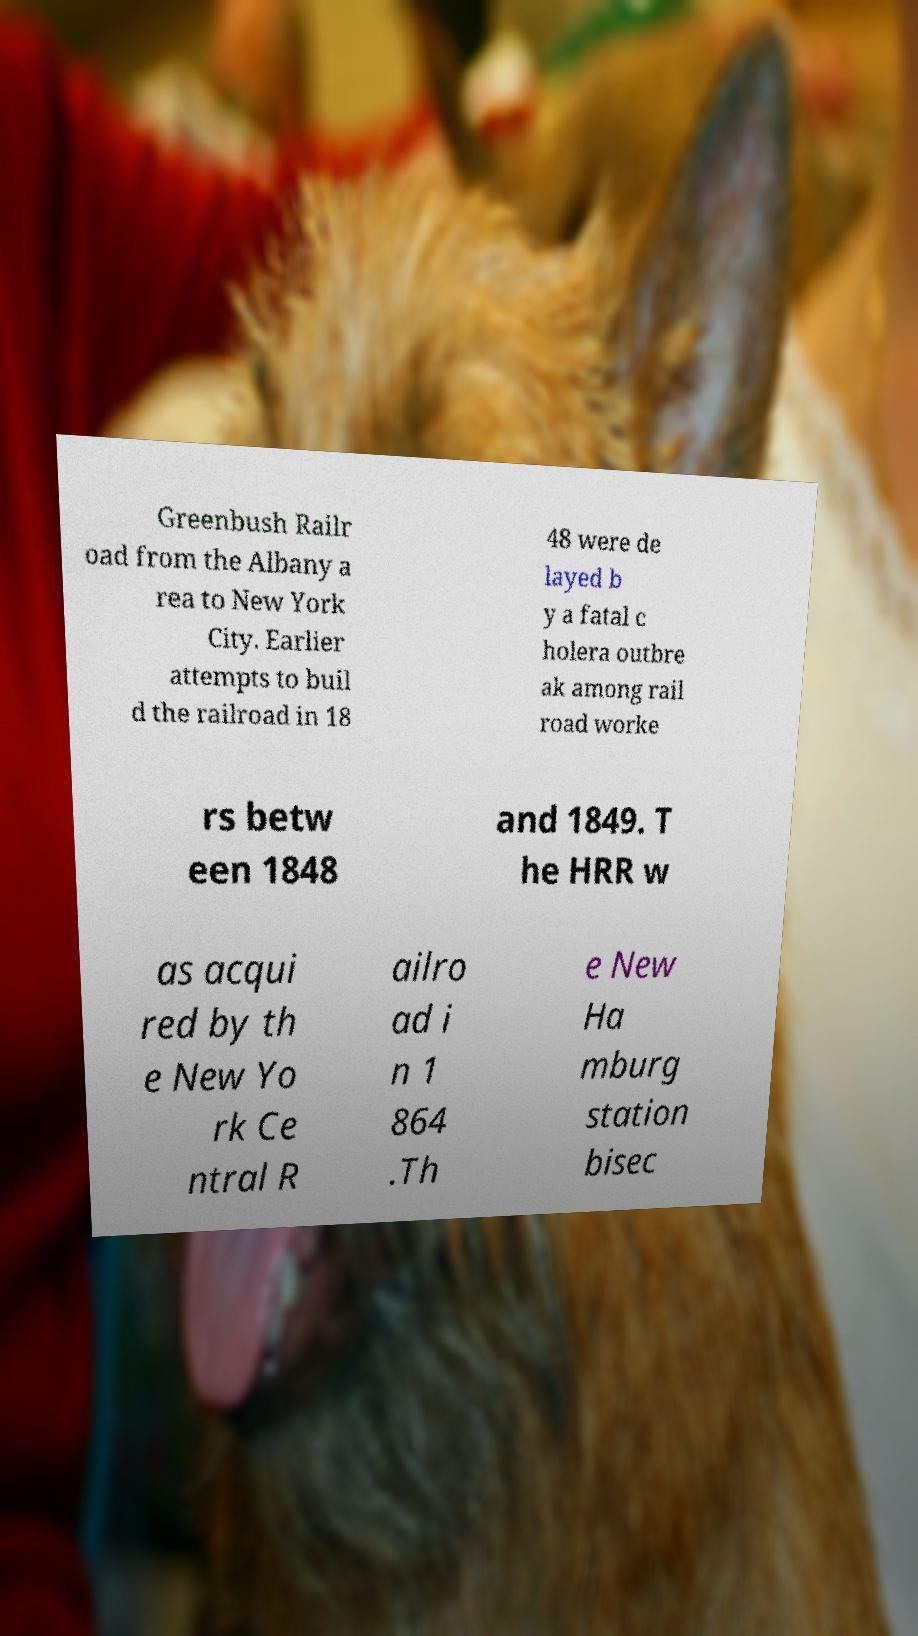There's text embedded in this image that I need extracted. Can you transcribe it verbatim? Greenbush Railr oad from the Albany a rea to New York City. Earlier attempts to buil d the railroad in 18 48 were de layed b y a fatal c holera outbre ak among rail road worke rs betw een 1848 and 1849. T he HRR w as acqui red by th e New Yo rk Ce ntral R ailro ad i n 1 864 .Th e New Ha mburg station bisec 